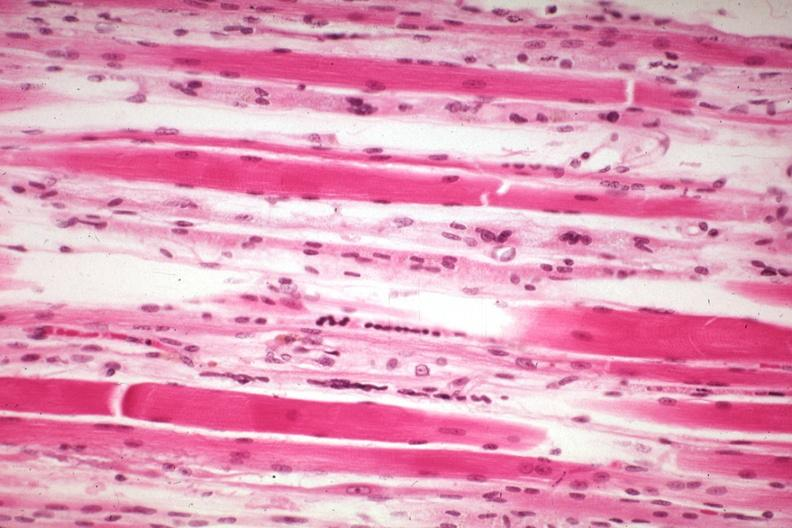does this image show high excellent atrophy secondary to steroid therapy?
Answer the question using a single word or phrase. Yes 